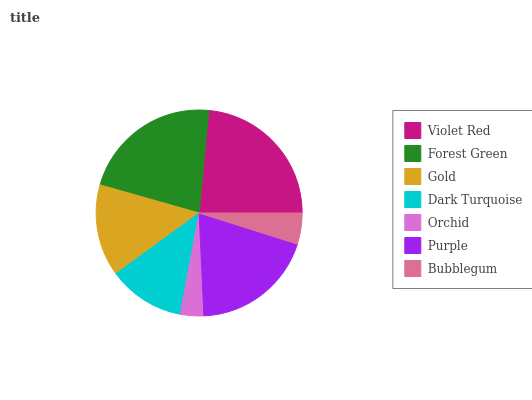Is Orchid the minimum?
Answer yes or no. Yes. Is Violet Red the maximum?
Answer yes or no. Yes. Is Forest Green the minimum?
Answer yes or no. No. Is Forest Green the maximum?
Answer yes or no. No. Is Violet Red greater than Forest Green?
Answer yes or no. Yes. Is Forest Green less than Violet Red?
Answer yes or no. Yes. Is Forest Green greater than Violet Red?
Answer yes or no. No. Is Violet Red less than Forest Green?
Answer yes or no. No. Is Gold the high median?
Answer yes or no. Yes. Is Gold the low median?
Answer yes or no. Yes. Is Dark Turquoise the high median?
Answer yes or no. No. Is Dark Turquoise the low median?
Answer yes or no. No. 